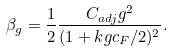<formula> <loc_0><loc_0><loc_500><loc_500>\beta _ { g } = \frac { 1 } { 2 } \frac { C _ { a d j } g ^ { 2 } } { ( 1 + k g c _ { F } / 2 ) ^ { 2 } } .</formula> 